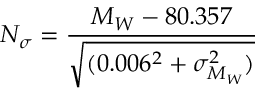<formula> <loc_0><loc_0><loc_500><loc_500>N _ { \sigma } = \frac { M _ { W } - 8 0 . 3 5 7 } { \sqrt { ( 0 . 0 0 6 ^ { 2 } + \sigma _ { M _ { W } } ^ { 2 } ) } }</formula> 